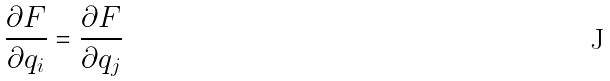Convert formula to latex. <formula><loc_0><loc_0><loc_500><loc_500>\frac { \partial F } { \partial q _ { i } } = \frac { \partial F } { \partial q _ { j } }</formula> 